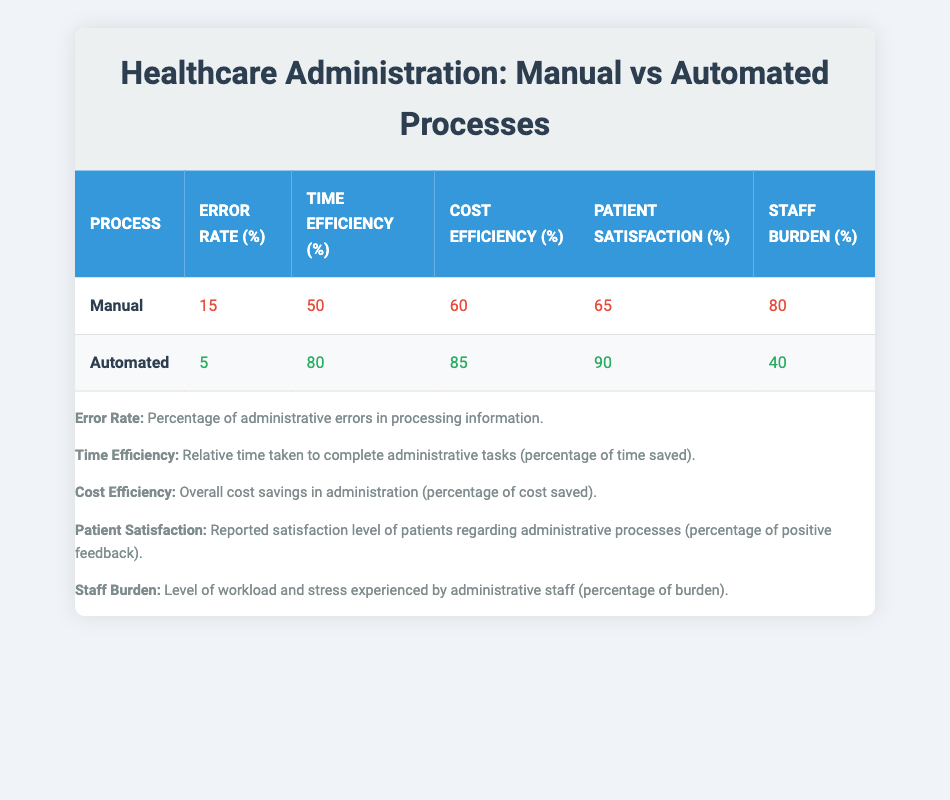What is the error rate for the manual process? The table indicates that the error rate for the manual process is listed under the corresponding column. It shows a value of 15.
Answer: 15 What percentage of cost savings does the automated process provide? From the table, the cost efficiency for the automated process is found in the cost efficiency column, which is 85.
Answer: 85 Which process has a higher patient satisfaction rating? By comparing the patient satisfaction percentages in the table, we see that the automated process has a satisfaction rating of 90, while the manual process has a rating of 65. Thus, automated is higher.
Answer: Automated What is the difference in time efficiency between the two processes? The time efficiency for the automated process is 80 and for the manual process, it is 50. The difference is calculated as 80 - 50, which equals 30.
Answer: 30 Is the staff burden for the automated process lower than that for the manual process? The staff burden for the manual process is 80, and for the automated process, it is 40. Since 40 is less than 80, the statement is true.
Answer: Yes What is the average error rate of both processes combined? The error rates for both processes are 15 and 5. To calculate the average, we sum them (15 + 5) to get 20. Then, divide by the number of processes (2), resulting in 20 / 2 = 10.
Answer: 10 Which process has a higher time efficiency, and by how much? The time efficiency of the automated process is 80, while that of the manual process is 50. The difference in time efficiency is 80 - 50 = 30, indicating automated is higher by 30.
Answer: Automated, 30 Is the manual process more cost-efficient than the automated process? The manual process reports a cost efficiency of 60, whereas the automated process shows 85. Since 60 is less than 85, the manual process is not more cost-efficient.
Answer: No 